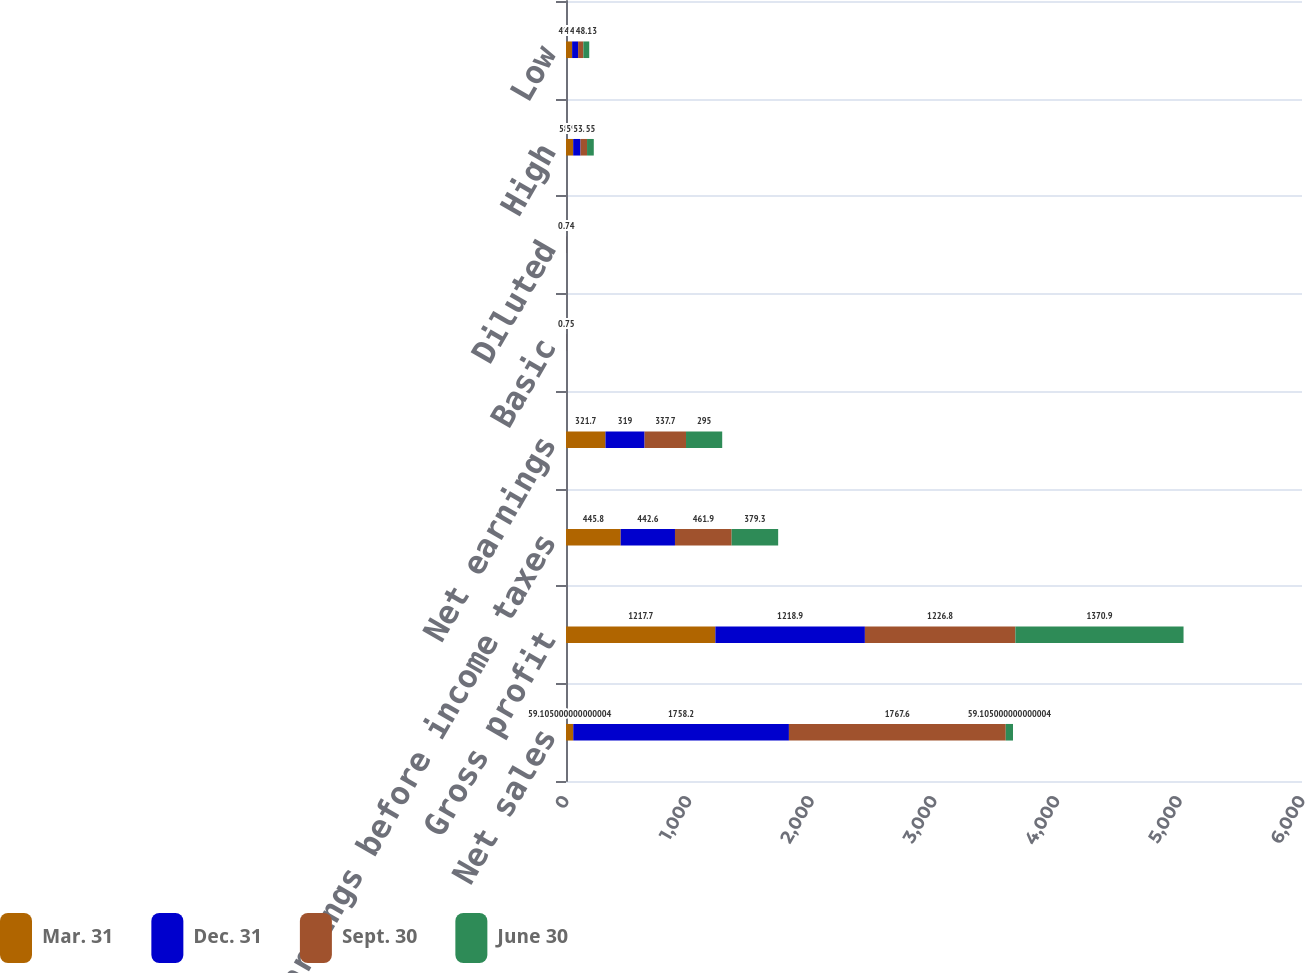Convert chart. <chart><loc_0><loc_0><loc_500><loc_500><stacked_bar_chart><ecel><fcel>Net sales<fcel>Gross profit<fcel>Earnings before income taxes<fcel>Net earnings<fcel>Basic<fcel>Diluted<fcel>High<fcel>Low<nl><fcel>Mar. 31<fcel>59.105<fcel>1217.7<fcel>445.8<fcel>321.7<fcel>0.81<fcel>0.8<fcel>58.49<fcel>49.85<nl><fcel>Dec. 31<fcel>1758.2<fcel>1218.9<fcel>442.6<fcel>319<fcel>0.8<fcel>0.8<fcel>59.72<fcel>48.76<nl><fcel>Sept. 30<fcel>1767.6<fcel>1226.8<fcel>461.9<fcel>337.7<fcel>0.85<fcel>0.85<fcel>53.29<fcel>42.74<nl><fcel>June 30<fcel>59.105<fcel>1370.9<fcel>379.3<fcel>295<fcel>0.75<fcel>0.74<fcel>55<fcel>48.13<nl></chart> 